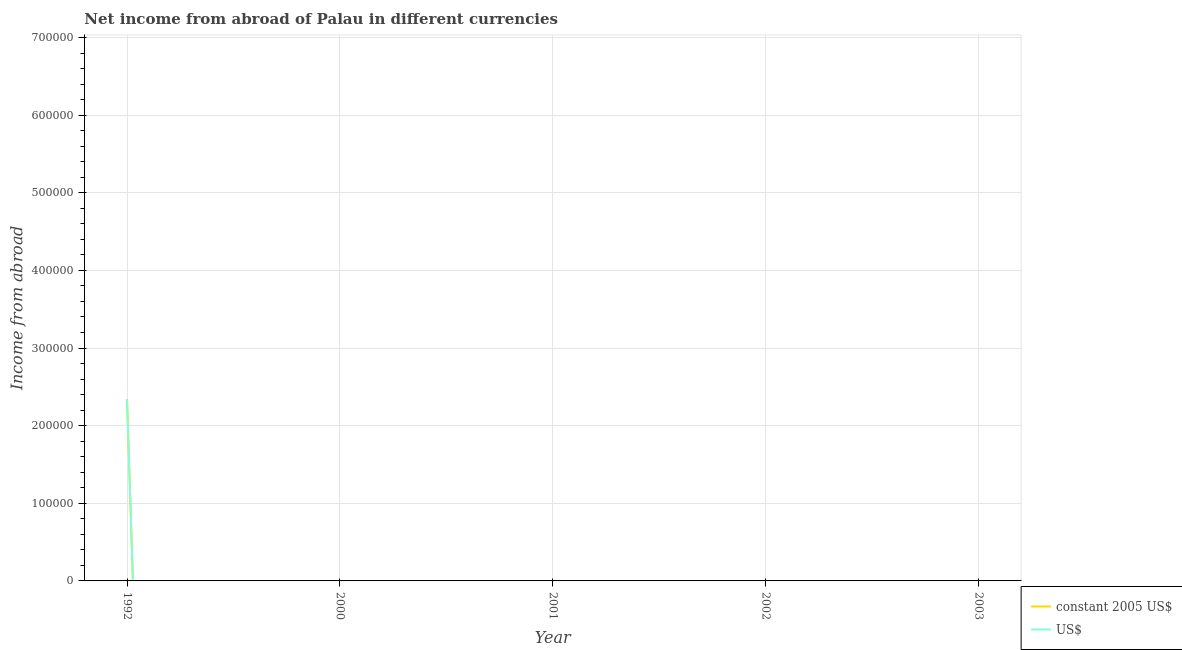How many different coloured lines are there?
Give a very brief answer. 2. Does the line corresponding to income from abroad in us$ intersect with the line corresponding to income from abroad in constant 2005 us$?
Offer a terse response. Yes. Is the number of lines equal to the number of legend labels?
Your response must be concise. No. What is the income from abroad in constant 2005 us$ in 2002?
Make the answer very short. 0. Across all years, what is the maximum income from abroad in us$?
Keep it short and to the point. 2.34e+05. In which year was the income from abroad in constant 2005 us$ maximum?
Your response must be concise. 1992. What is the total income from abroad in constant 2005 us$ in the graph?
Your answer should be compact. 2.34e+05. What is the average income from abroad in constant 2005 us$ per year?
Make the answer very short. 4.68e+04. In the year 1992, what is the difference between the income from abroad in us$ and income from abroad in constant 2005 us$?
Make the answer very short. 0. In how many years, is the income from abroad in constant 2005 us$ greater than 440000 units?
Provide a short and direct response. 0. What is the difference between the highest and the lowest income from abroad in constant 2005 us$?
Provide a short and direct response. 2.34e+05. In how many years, is the income from abroad in constant 2005 us$ greater than the average income from abroad in constant 2005 us$ taken over all years?
Provide a short and direct response. 1. How many lines are there?
Your response must be concise. 2. What is the difference between two consecutive major ticks on the Y-axis?
Keep it short and to the point. 1.00e+05. Does the graph contain any zero values?
Keep it short and to the point. Yes. How many legend labels are there?
Your answer should be very brief. 2. How are the legend labels stacked?
Keep it short and to the point. Vertical. What is the title of the graph?
Your response must be concise. Net income from abroad of Palau in different currencies. Does "Young" appear as one of the legend labels in the graph?
Your response must be concise. No. What is the label or title of the Y-axis?
Offer a terse response. Income from abroad. What is the Income from abroad of constant 2005 US$ in 1992?
Provide a succinct answer. 2.34e+05. What is the Income from abroad of US$ in 1992?
Your response must be concise. 2.34e+05. What is the Income from abroad of constant 2005 US$ in 2000?
Offer a terse response. 0. What is the Income from abroad in US$ in 2000?
Your answer should be very brief. 0. What is the Income from abroad in constant 2005 US$ in 2001?
Give a very brief answer. 0. What is the Income from abroad of US$ in 2002?
Provide a short and direct response. 0. What is the Income from abroad of constant 2005 US$ in 2003?
Keep it short and to the point. 0. What is the Income from abroad in US$ in 2003?
Your answer should be very brief. 0. Across all years, what is the maximum Income from abroad of constant 2005 US$?
Provide a succinct answer. 2.34e+05. Across all years, what is the maximum Income from abroad in US$?
Offer a very short reply. 2.34e+05. What is the total Income from abroad in constant 2005 US$ in the graph?
Your answer should be very brief. 2.34e+05. What is the total Income from abroad in US$ in the graph?
Ensure brevity in your answer.  2.34e+05. What is the average Income from abroad in constant 2005 US$ per year?
Your answer should be very brief. 4.68e+04. What is the average Income from abroad in US$ per year?
Provide a short and direct response. 4.68e+04. What is the difference between the highest and the lowest Income from abroad of constant 2005 US$?
Ensure brevity in your answer.  2.34e+05. What is the difference between the highest and the lowest Income from abroad in US$?
Your response must be concise. 2.34e+05. 